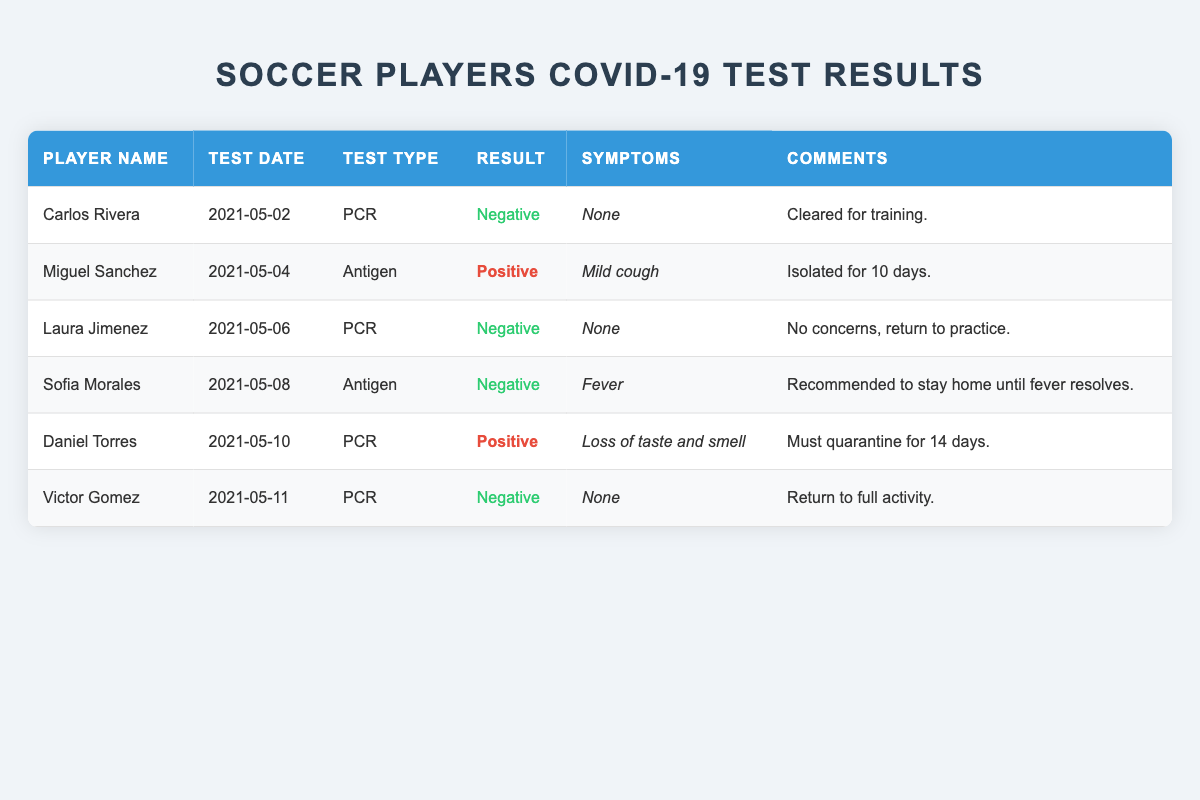What were the results of Carlos Rivera's COVID-19 test? Carlos Rivera's test result is listed in the table under the 'Result' column, where it's shown as 'Negative'.
Answer: Negative How many players tested positive for COVID-19? By scanning the 'Result' column, we see that only Miguel Sanchez and Daniel Torres have 'Positive' results, totaling 2 players who tested positive.
Answer: 2 What symptoms did Laura Jimenez report? Laura Jimenez's entry in the 'Symptoms' column states 'None', indicating she reported no symptoms.
Answer: None Is Sofia Morales allowed to return to practice immediately? The 'Comments' column for Sofia Morales indicates she is recommended to stay home until her fever resolves, which means she is not allowed to return to practice immediately.
Answer: No What is the most frequent test type used among the players? Counting the occurrences of different test types, PCR appears 4 times, and Antigen appears 2 times. Since 4 is greater than 2, PCR is the most frequent test type.
Answer: PCR What is the average number of days players were isolated or quarantined based on positive results? Miguel Sanchez must isolate for 10 days, and Daniel Torres must quarantine for 14 days. Adding these gives 24 days. Dividing by 2 positive cases: 24/2 = 12.
Answer: 12 Did any player report loss of taste and smell? From the 'Symptoms' column, only Daniel Torres reported 'Loss of taste and smell', confirming he is the only player with this symptom.
Answer: Yes Who received a negative result on May 6th? The table indicates that Laura Jimenez's test on May 6th resulted in 'Negative', making her the player with this result on that date.
Answer: Laura Jimenez What actions were recommended for players with symptoms? Players Miguel Sanchez and Sofia Morales had symptoms. Miguel was isolated for 10 days, and Sofia was advised to stay home until her fever resolved, demonstrating that actions were taken based on symptoms.
Answer: Isolation and stay home Which player had the earliest test date? Scanning the 'Test Date' column, Carlos Rivera tested on May 2nd, which is the earliest date listed, making him the first player tested.
Answer: Carlos Rivera 